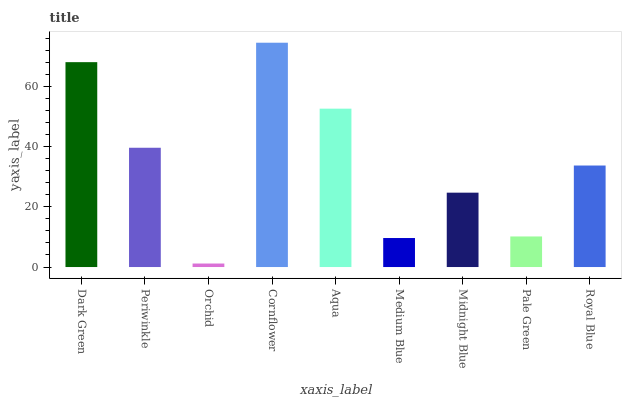Is Orchid the minimum?
Answer yes or no. Yes. Is Cornflower the maximum?
Answer yes or no. Yes. Is Periwinkle the minimum?
Answer yes or no. No. Is Periwinkle the maximum?
Answer yes or no. No. Is Dark Green greater than Periwinkle?
Answer yes or no. Yes. Is Periwinkle less than Dark Green?
Answer yes or no. Yes. Is Periwinkle greater than Dark Green?
Answer yes or no. No. Is Dark Green less than Periwinkle?
Answer yes or no. No. Is Royal Blue the high median?
Answer yes or no. Yes. Is Royal Blue the low median?
Answer yes or no. Yes. Is Orchid the high median?
Answer yes or no. No. Is Aqua the low median?
Answer yes or no. No. 